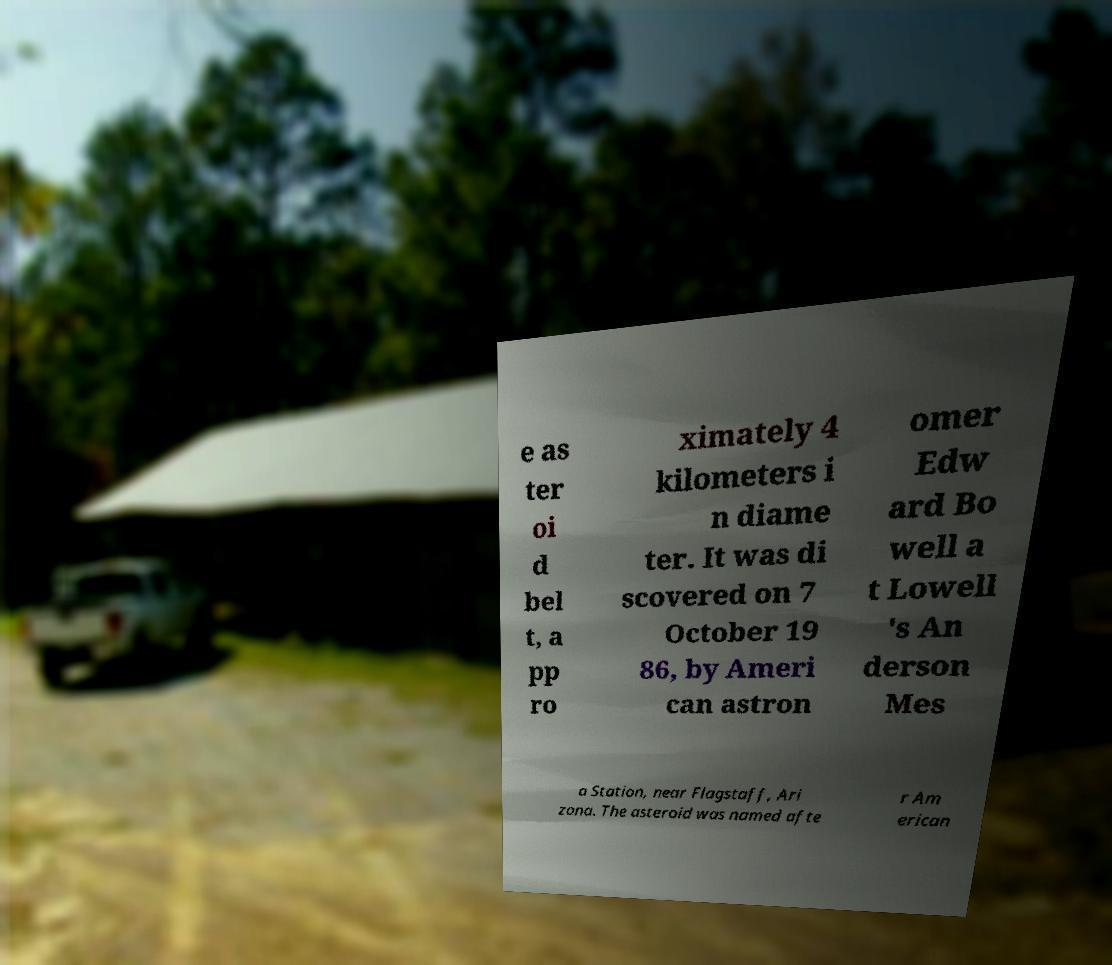Please identify and transcribe the text found in this image. e as ter oi d bel t, a pp ro ximately 4 kilometers i n diame ter. It was di scovered on 7 October 19 86, by Ameri can astron omer Edw ard Bo well a t Lowell 's An derson Mes a Station, near Flagstaff, Ari zona. The asteroid was named afte r Am erican 